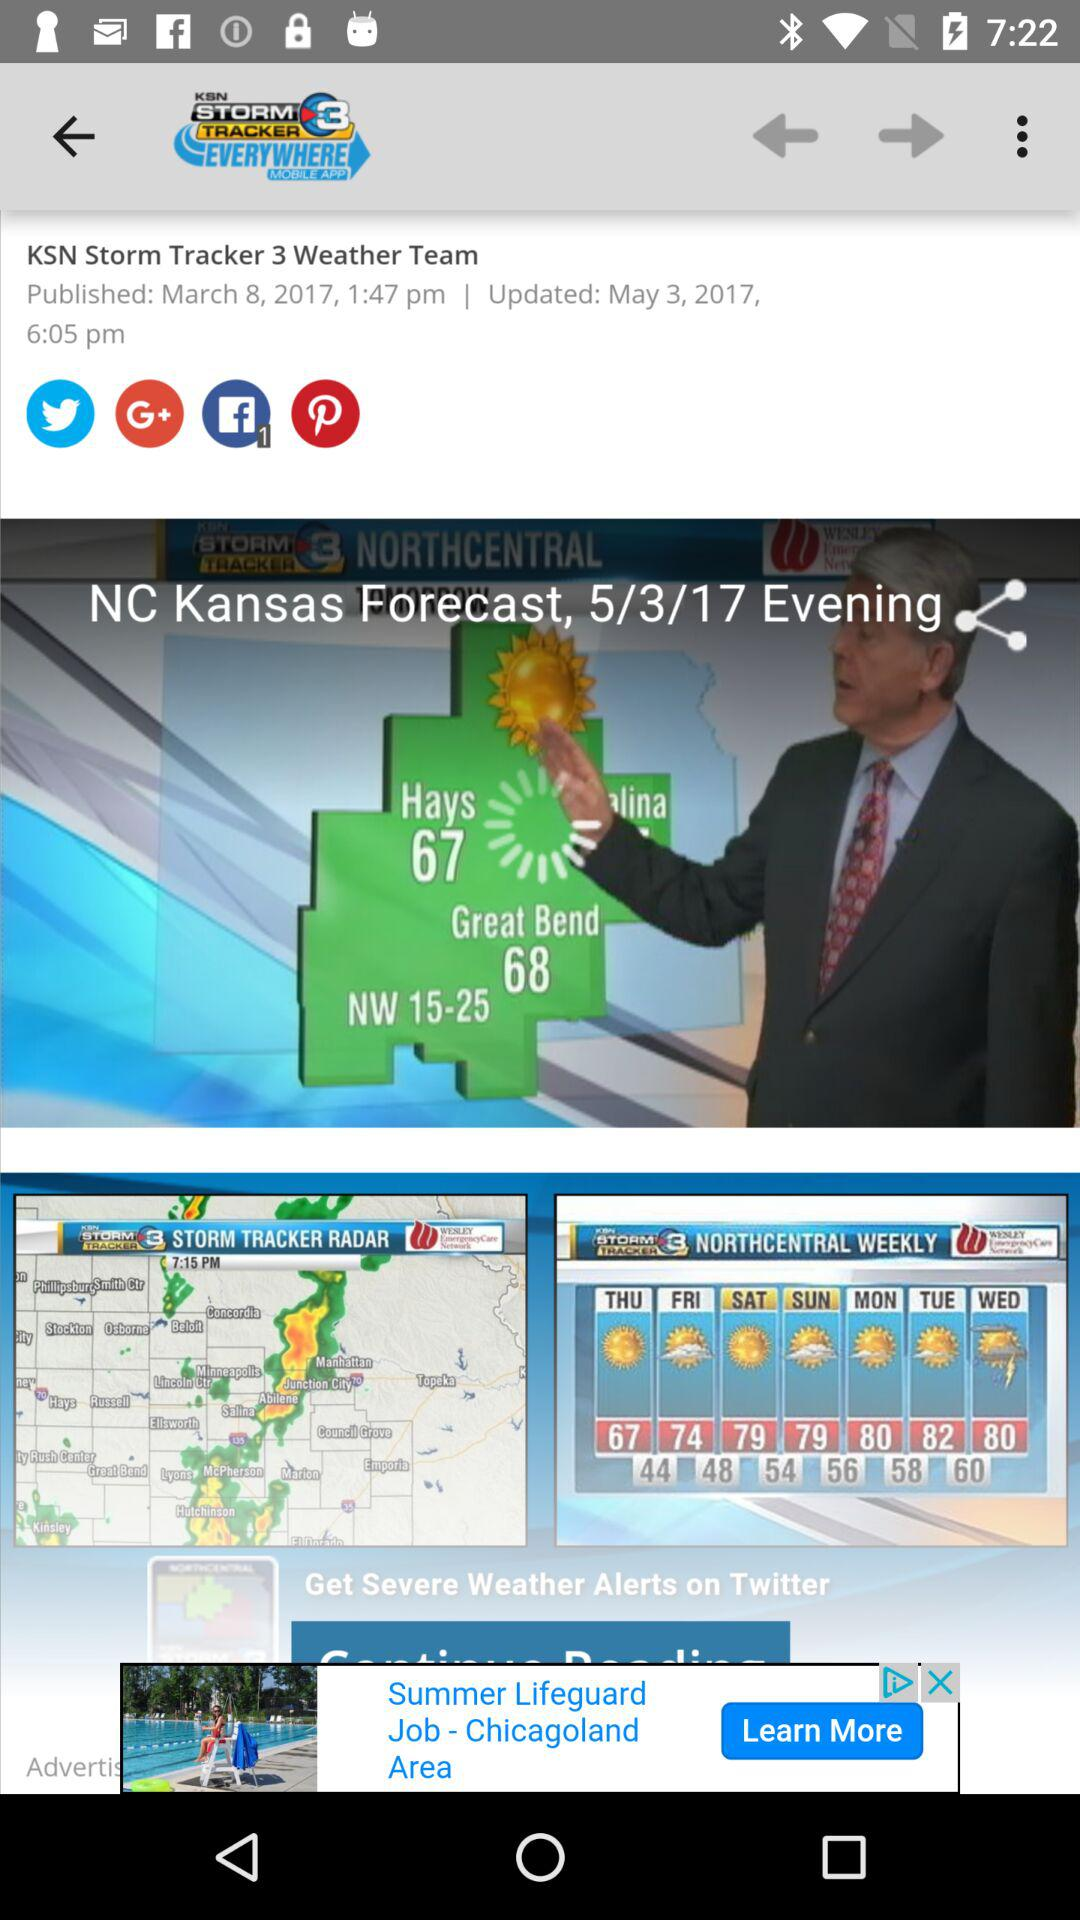What is the app's name? The app's name is "KSN STORM TRACKER 3 EVERYWHERE MOBILE APP". 